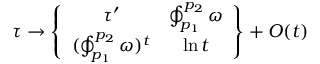<formula> <loc_0><loc_0><loc_500><loc_500>\tau \to \left \{ \begin{array} { c c } { { \tau ^ { \prime } } } & { { \oint _ { p _ { 1 } } ^ { p _ { 2 } } \omega } } \\ { { ( \oint _ { p _ { 1 } } ^ { p _ { 2 } } \omega ) ^ { t } } } & { \ln t } \end{array} \right \} + O ( t )</formula> 